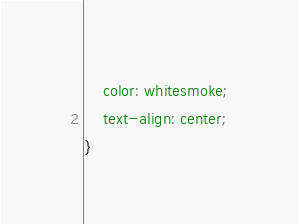<code> <loc_0><loc_0><loc_500><loc_500><_CSS_>    color: whitesmoke;
    text-align: center;
}</code> 